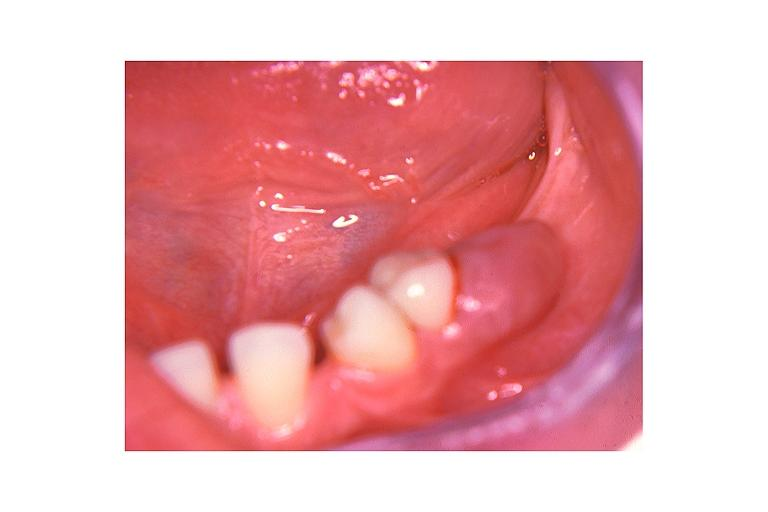s oral present?
Answer the question using a single word or phrase. Yes 